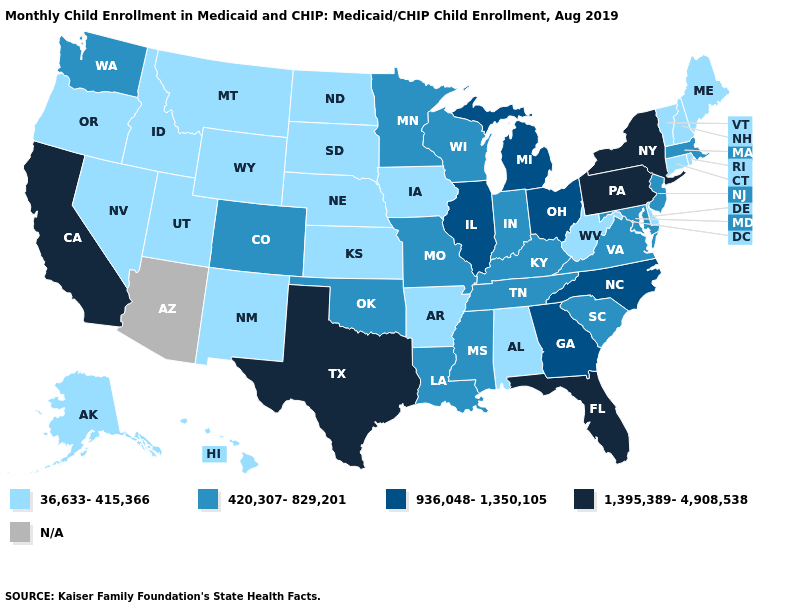What is the lowest value in the USA?
Keep it brief. 36,633-415,366. Among the states that border Indiana , does Michigan have the highest value?
Concise answer only. Yes. What is the value of Virginia?
Concise answer only. 420,307-829,201. Name the states that have a value in the range 420,307-829,201?
Write a very short answer. Colorado, Indiana, Kentucky, Louisiana, Maryland, Massachusetts, Minnesota, Mississippi, Missouri, New Jersey, Oklahoma, South Carolina, Tennessee, Virginia, Washington, Wisconsin. Among the states that border New Mexico , does Utah have the highest value?
Quick response, please. No. Name the states that have a value in the range 936,048-1,350,105?
Answer briefly. Georgia, Illinois, Michigan, North Carolina, Ohio. How many symbols are there in the legend?
Give a very brief answer. 5. Among the states that border Maine , which have the highest value?
Write a very short answer. New Hampshire. What is the highest value in the MidWest ?
Be succinct. 936,048-1,350,105. What is the value of North Carolina?
Answer briefly. 936,048-1,350,105. Name the states that have a value in the range 36,633-415,366?
Be succinct. Alabama, Alaska, Arkansas, Connecticut, Delaware, Hawaii, Idaho, Iowa, Kansas, Maine, Montana, Nebraska, Nevada, New Hampshire, New Mexico, North Dakota, Oregon, Rhode Island, South Dakota, Utah, Vermont, West Virginia, Wyoming. What is the value of Kentucky?
Keep it brief. 420,307-829,201. Name the states that have a value in the range 1,395,389-4,908,538?
Concise answer only. California, Florida, New York, Pennsylvania, Texas. Does the first symbol in the legend represent the smallest category?
Write a very short answer. Yes. What is the value of Iowa?
Write a very short answer. 36,633-415,366. 